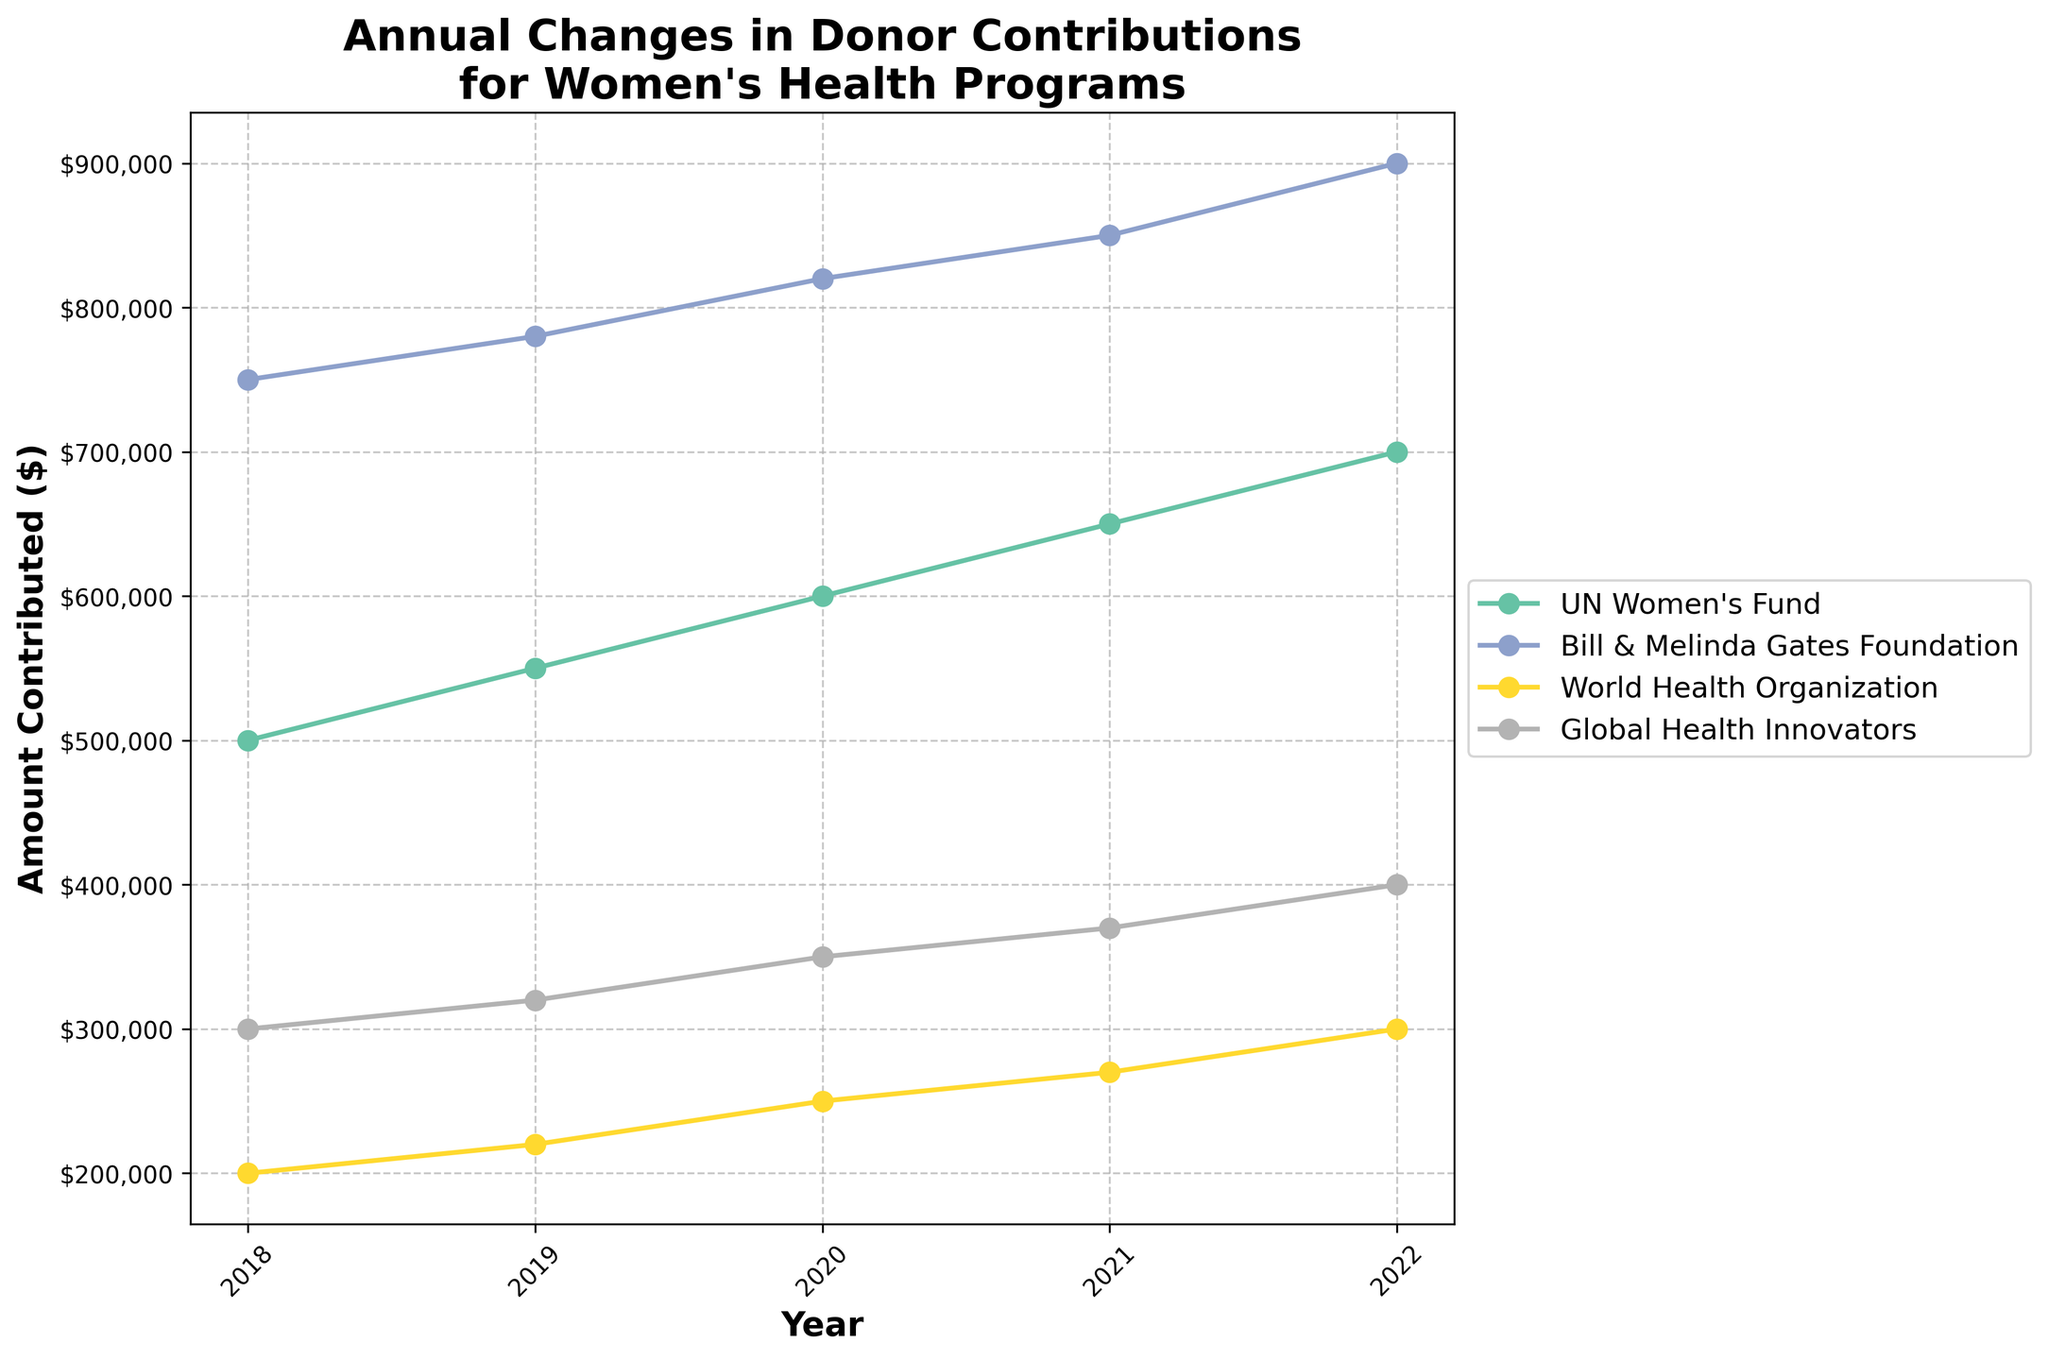What's the title of the figure? The title is prominently displayed at the top of the figure. It reads "Annual Changes in Donor Contributions for Women's Health Programs."
Answer: Annual Changes in Donor Contributions for Women's Health Programs Which organization contributed the most in 2022? By looking at the values plotted for the year 2022, the highest value is attributed to the Bill & Melinda Gates Foundation.
Answer: Bill & Melinda Gates Foundation What are the unique years shown on the x-axis? The x-axis ticks represent the years. These are indicated as 2018, 2019, 2020, 2021, and 2022.
Answer: 2018, 2019, 2020, 2021, 2022 How much did the World Health Organization increase its contribution from 2019 to 2020? The World Health Organization's contribution in 2019 was $220,000 and in 2020, it was $250,000. The increase is calculated as $250,000 - $220,000.
Answer: $30,000 Which organization has the most consistent increase in contributions over the years? By observing the slope and intervals of the lines representing each organization, the UN Women's Fund shows the most consistent annual increase.
Answer: UN Women's Fund What was the total contribution of Global Health Innovators from 2018 to 2022? Adding Global Health Innovators' contributions for each year: $300,000 (2018) + $320,000 (2019) + $350,000 (2020) + $370,000 (2021) + $400,000 (2022), sums up to $1,740,000.
Answer: $1,740,000 Compare the contributions of UN Women's Fund and the World Health Organization in 2021. Which one is higher and by how much? In 2021, UN Women’s Fund contributed $650,000 and World Health Organization contributed $270,000. The difference is $650,000 - $270,000.
Answer: UN Women's Fund by $380,000 What is the percentage increase in contributions from the Bill & Melinda Gates Foundation from 2018 to 2022? The contributions from Bill & Melinda Gates Foundation in 2018 and 2022 were $750,000 and $900,000 respectively. The percentage increase is calculated as ((900,000 - 750,000) / 750,000) * 100.
Answer: 20% Which organization had the smallest contribution in 2019 and how much did they contribute? By examining the plot points for 2019, the smallest contribution is from the World Health Organization with $220,000.
Answer: World Health Organization, $220,000 What was the overall trend in contributions for Global Health Innovators between 2018 and 2022? The plot shows an upward trend for Global Health Innovators' contributions from $300,000 in 2018 to $400,000 in 2022, indicating a gradual increase.
Answer: Upward Trend 